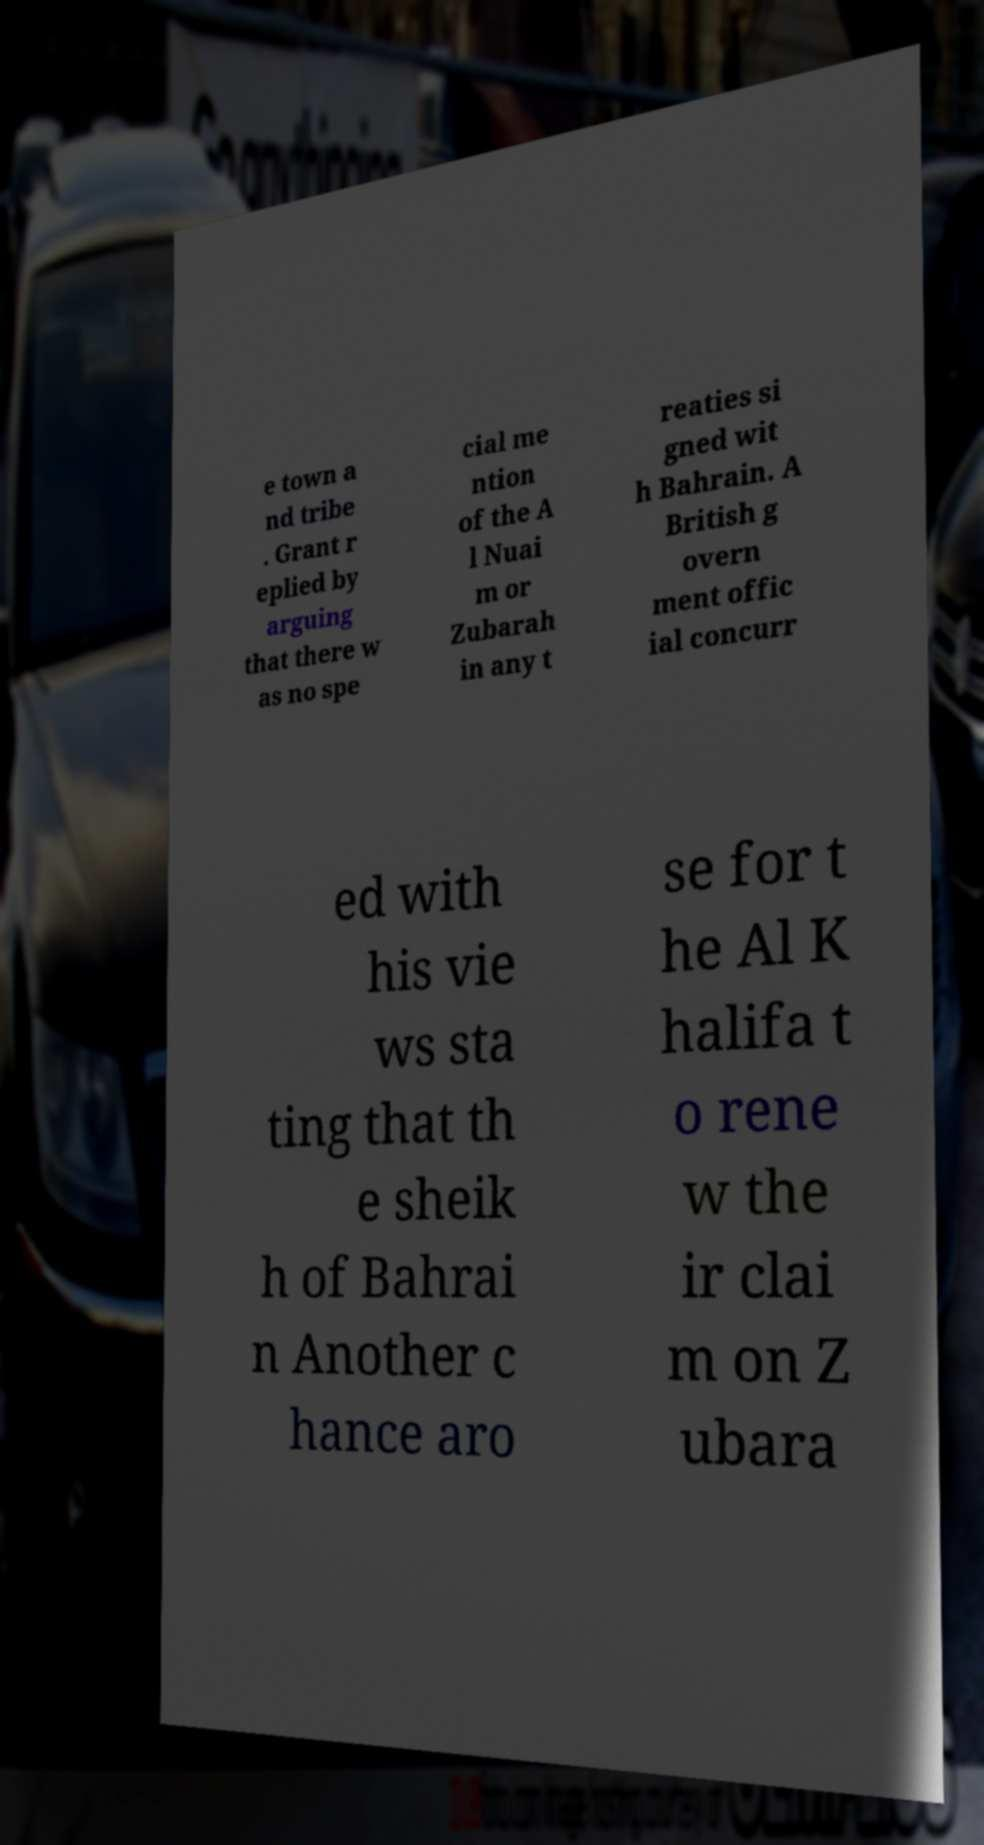Please identify and transcribe the text found in this image. e town a nd tribe . Grant r eplied by arguing that there w as no spe cial me ntion of the A l Nuai m or Zubarah in any t reaties si gned wit h Bahrain. A British g overn ment offic ial concurr ed with his vie ws sta ting that th e sheik h of Bahrai n Another c hance aro se for t he Al K halifa t o rene w the ir clai m on Z ubara 